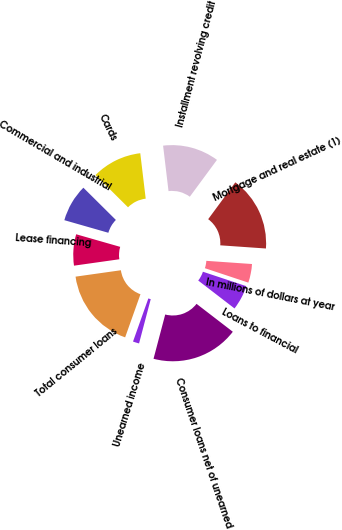Convert chart. <chart><loc_0><loc_0><loc_500><loc_500><pie_chart><fcel>In millions of dollars at year<fcel>Mortgage and real estate (1)<fcel>Installment revolving credit<fcel>Cards<fcel>Commercial and industrial<fcel>Lease financing<fcel>Total consumer loans<fcel>Unearned income<fcel>Consumer loans net of unearned<fcel>Loans to financial<nl><fcel>4.0%<fcel>16.0%<fcel>12.0%<fcel>10.67%<fcel>8.0%<fcel>6.67%<fcel>17.33%<fcel>1.33%<fcel>18.67%<fcel>5.33%<nl></chart> 